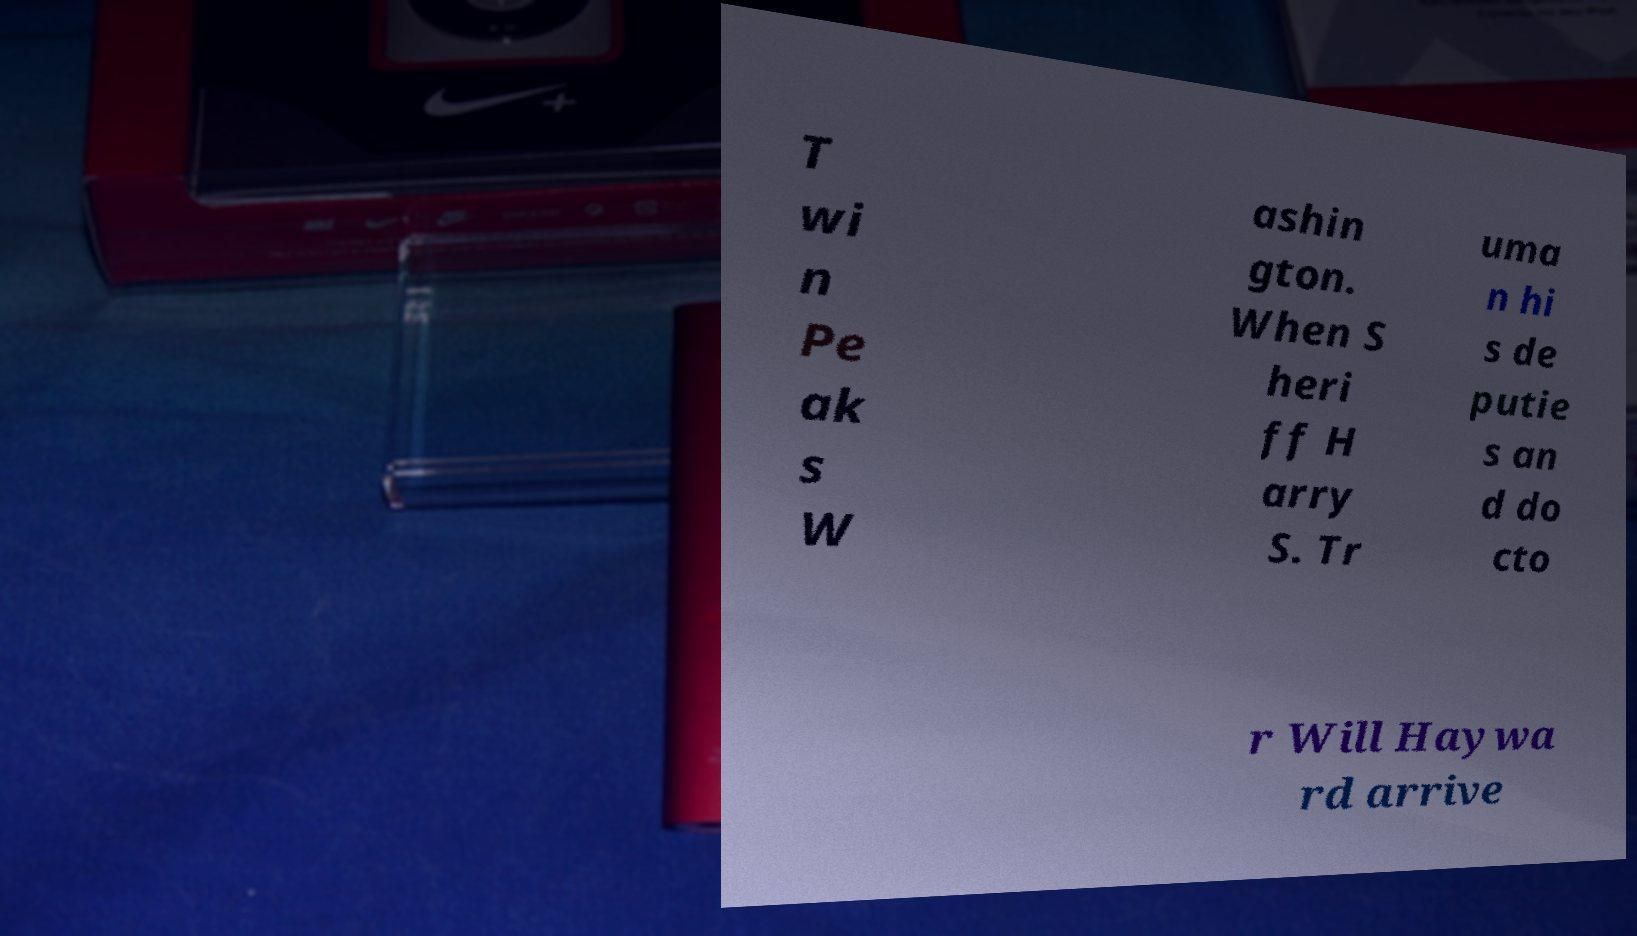There's text embedded in this image that I need extracted. Can you transcribe it verbatim? T wi n Pe ak s W ashin gton. When S heri ff H arry S. Tr uma n hi s de putie s an d do cto r Will Haywa rd arrive 